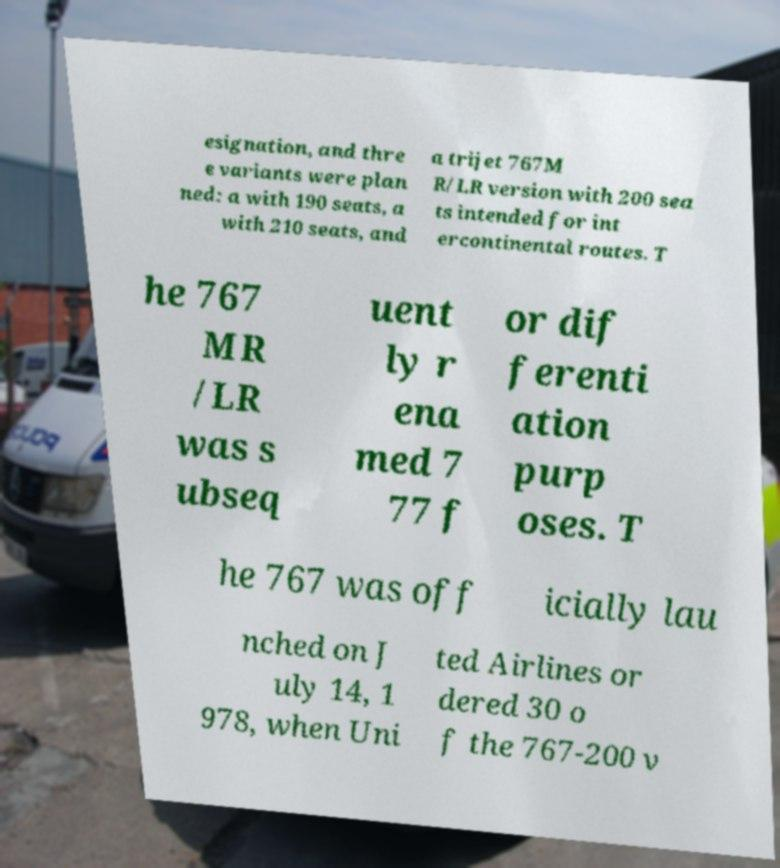Can you accurately transcribe the text from the provided image for me? esignation, and thre e variants were plan ned: a with 190 seats, a with 210 seats, and a trijet 767M R/LR version with 200 sea ts intended for int ercontinental routes. T he 767 MR /LR was s ubseq uent ly r ena med 7 77 f or dif ferenti ation purp oses. T he 767 was off icially lau nched on J uly 14, 1 978, when Uni ted Airlines or dered 30 o f the 767-200 v 